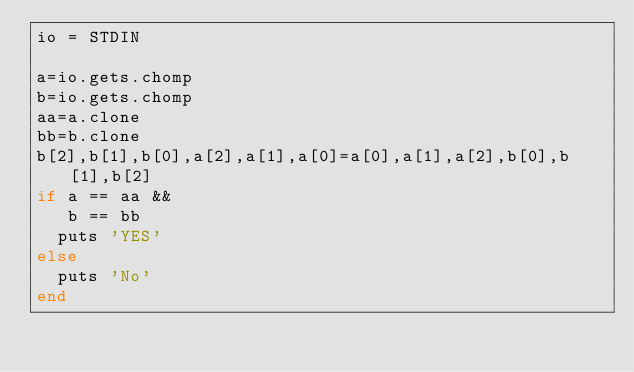<code> <loc_0><loc_0><loc_500><loc_500><_Ruby_>io = STDIN

a=io.gets.chomp
b=io.gets.chomp
aa=a.clone
bb=b.clone
b[2],b[1],b[0],a[2],a[1],a[0]=a[0],a[1],a[2],b[0],b[1],b[2]
if a == aa &&
   b == bb
  puts 'YES'
else
  puts 'No'
end
</code> 